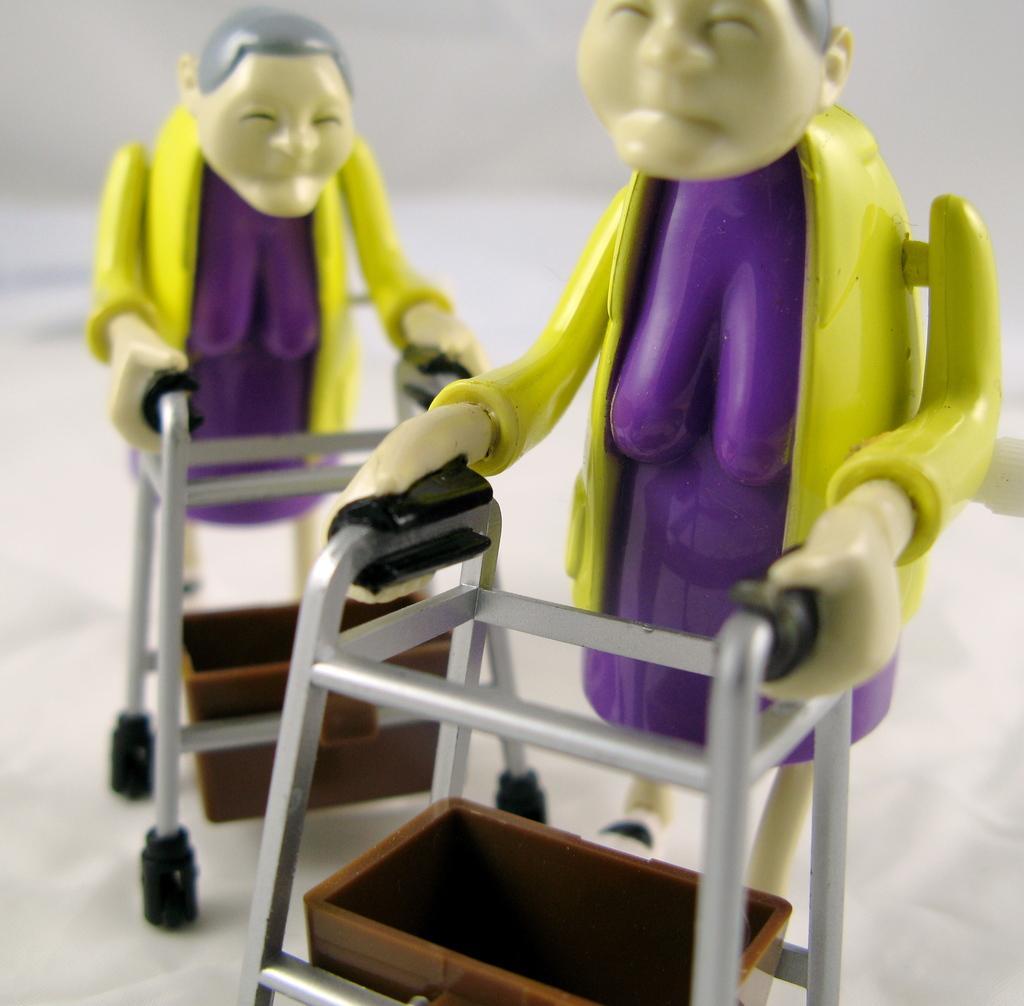Can you describe this image briefly? Here we can see two women toys holding supporting stands to walk on a platform. 